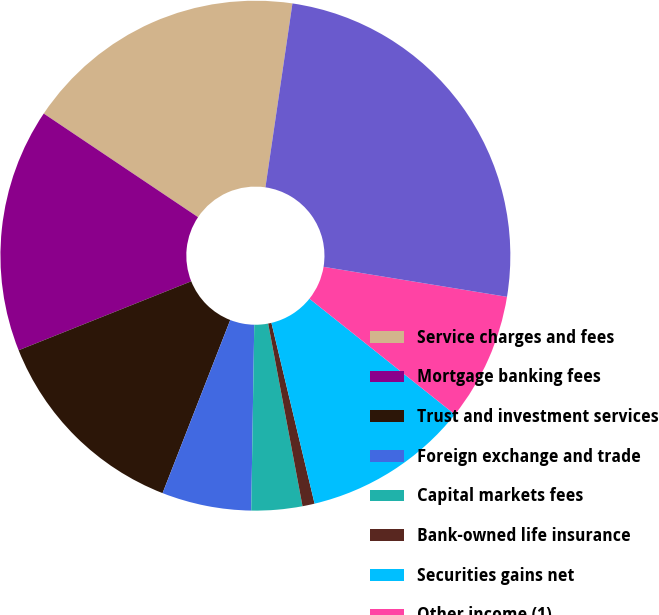Convert chart to OTSL. <chart><loc_0><loc_0><loc_500><loc_500><pie_chart><fcel>Service charges and fees<fcel>Mortgage banking fees<fcel>Trust and investment services<fcel>Foreign exchange and trade<fcel>Capital markets fees<fcel>Bank-owned life insurance<fcel>Securities gains net<fcel>Other income (1)<fcel>Noninterest income<nl><fcel>17.91%<fcel>15.46%<fcel>13.02%<fcel>5.67%<fcel>3.22%<fcel>0.77%<fcel>10.57%<fcel>8.12%<fcel>25.26%<nl></chart> 